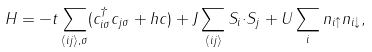Convert formula to latex. <formula><loc_0><loc_0><loc_500><loc_500>H = - t \sum _ { \langle i j \rangle , \sigma } ( c ^ { \dagger } _ { i \sigma } c _ { j \sigma } + h c ) + J \sum _ { \langle i j \rangle } { S } _ { i } { \cdot } { S } _ { j } + U \sum _ { i } n _ { i \uparrow } n _ { i \downarrow } ,</formula> 